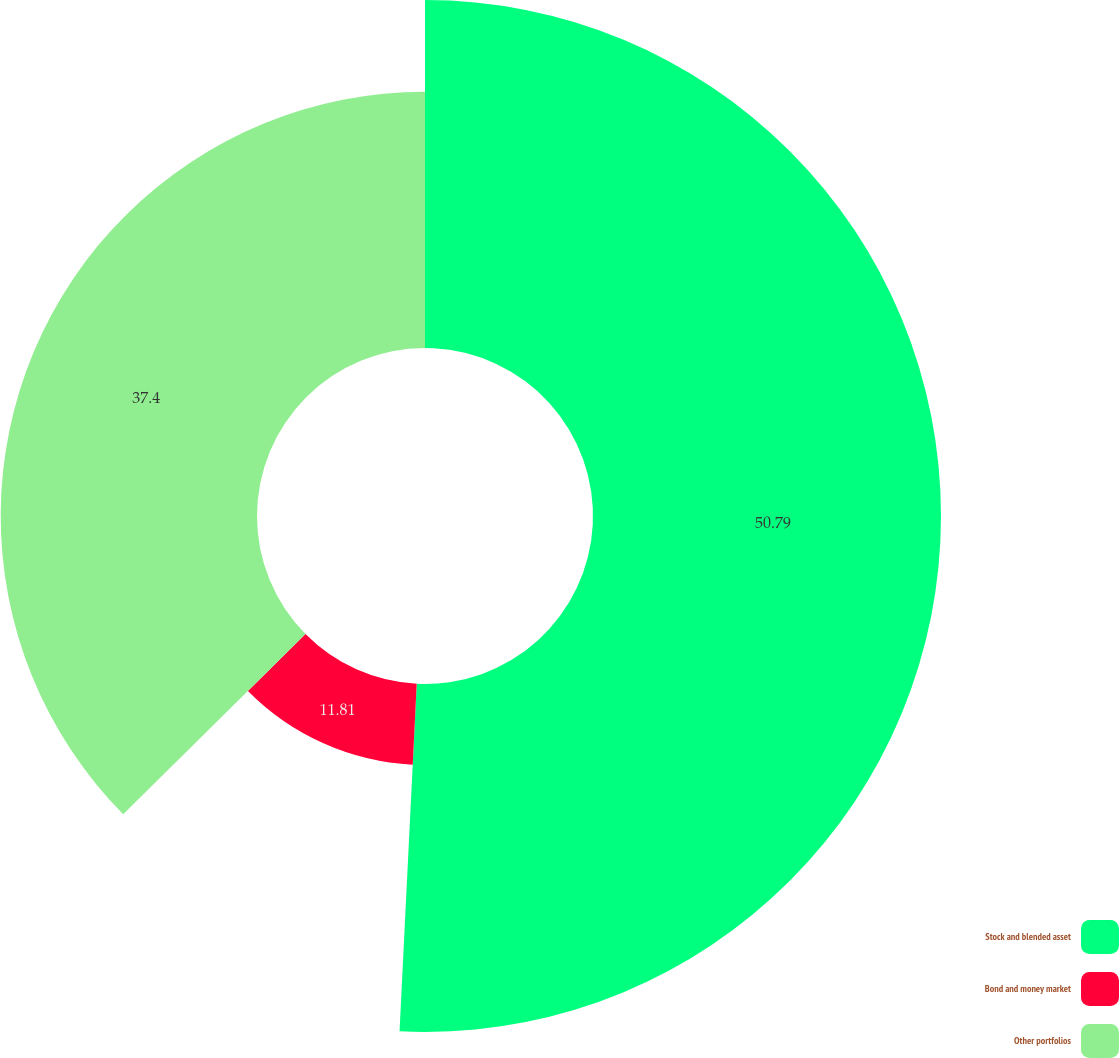<chart> <loc_0><loc_0><loc_500><loc_500><pie_chart><fcel>Stock and blended asset<fcel>Bond and money market<fcel>Other portfolios<nl><fcel>50.78%<fcel>11.81%<fcel>37.4%<nl></chart> 